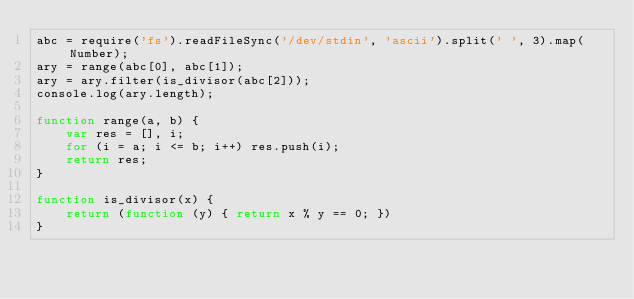Convert code to text. <code><loc_0><loc_0><loc_500><loc_500><_JavaScript_>abc = require('fs').readFileSync('/dev/stdin', 'ascii').split(' ', 3).map(Number);
ary = range(abc[0], abc[1]);
ary = ary.filter(is_divisor(abc[2]));
console.log(ary.length);

function range(a, b) {
	var res = [], i;
	for (i = a; i <= b; i++) res.push(i);
	return res;
}

function is_divisor(x) {
	return (function (y) { return x % y == 0; })
}</code> 